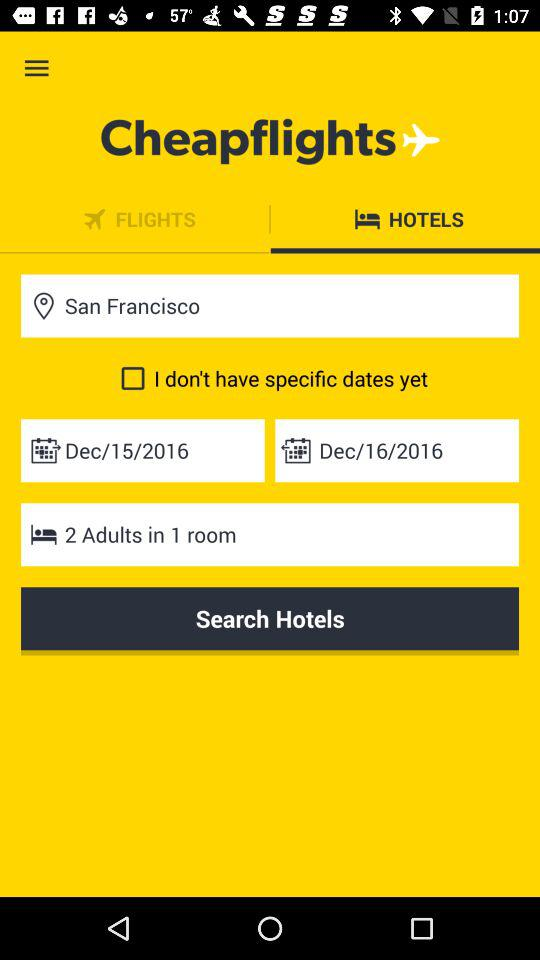What is the maximum number of adults that can be in one room? The maximum number of adults that can be in one room is 2. 